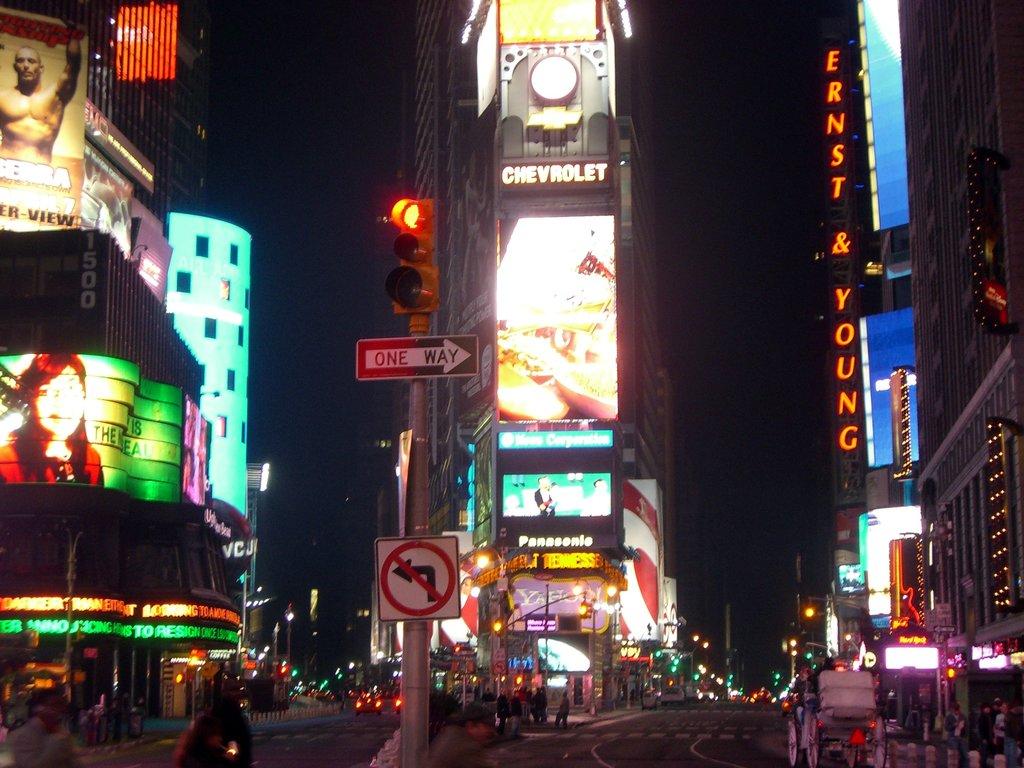What is the company name on the right?
Ensure brevity in your answer.  Ernst & young. 